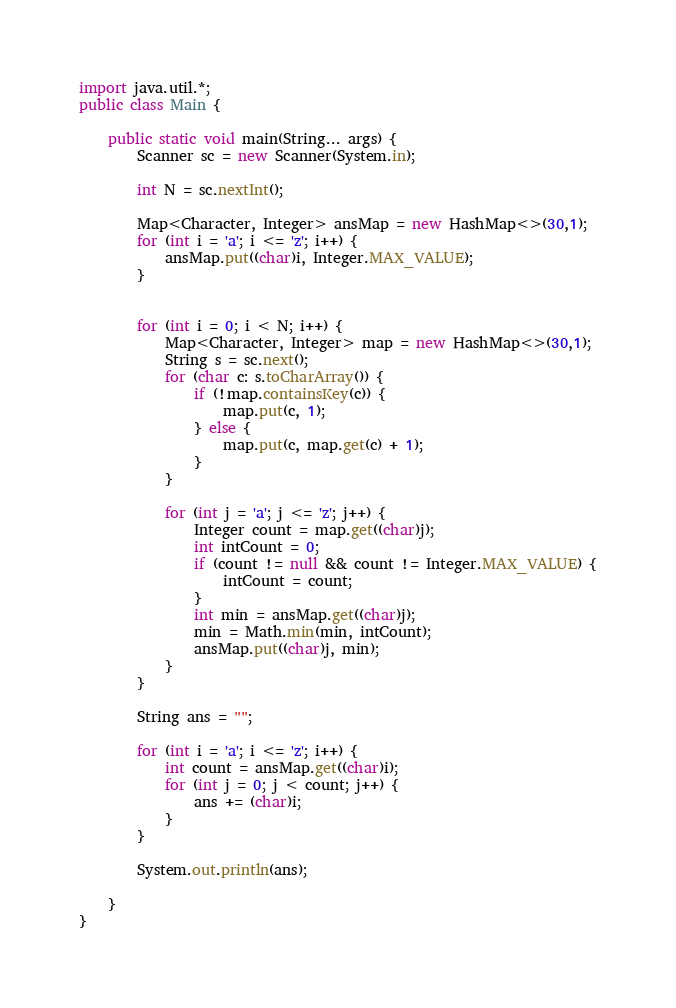Convert code to text. <code><loc_0><loc_0><loc_500><loc_500><_Java_>import java.util.*;
public class Main {
	
	public static void main(String... args) {
		Scanner sc = new Scanner(System.in);
		
		int N = sc.nextInt();
		
		Map<Character, Integer> ansMap = new HashMap<>(30,1);
		for (int i = 'a'; i <= 'z'; i++) {
			ansMap.put((char)i, Integer.MAX_VALUE);
		}
		
		
		for (int i = 0; i < N; i++) {
			Map<Character, Integer> map = new HashMap<>(30,1);
			String s = sc.next();
			for (char c: s.toCharArray()) {
				if (!map.containsKey(c)) {
					map.put(c, 1);
				} else {
					map.put(c, map.get(c) + 1);
				}
			}
			
			for (int j = 'a'; j <= 'z'; j++) {
				Integer count = map.get((char)j);
				int intCount = 0;
				if (count != null && count != Integer.MAX_VALUE) {
					intCount = count;
				}
				int min = ansMap.get((char)j);
				min = Math.min(min, intCount);
				ansMap.put((char)j, min);
			}
		}
		
		String ans = "";
		
		for (int i = 'a'; i <= 'z'; i++) {
			int count = ansMap.get((char)i);
			for (int j = 0; j < count; j++) {
				ans += (char)i;
			}
		}
		
		System.out.println(ans);
		
	}
}
</code> 